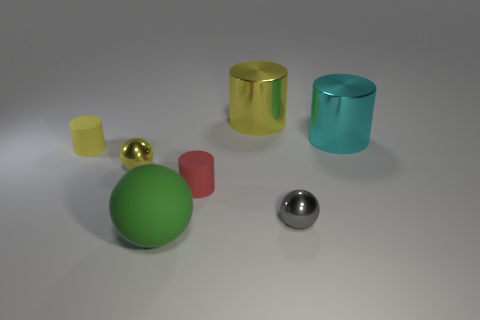What number of small things are red cylinders or green things?
Make the answer very short. 1. Is there a yellow metal cylinder that has the same size as the rubber sphere?
Keep it short and to the point. Yes. There is a small matte thing that is on the left side of the cylinder that is in front of the yellow metallic object that is in front of the big yellow object; what is its color?
Provide a succinct answer. Yellow. Does the green thing have the same material as the yellow cylinder that is behind the large cyan metal object?
Provide a succinct answer. No. There is a cyan shiny thing that is the same shape as the red object; what is its size?
Give a very brief answer. Large. Are there an equal number of yellow matte things on the right side of the yellow matte cylinder and tiny metal balls left of the matte sphere?
Your response must be concise. No. What number of other objects are the same material as the gray sphere?
Ensure brevity in your answer.  3. Are there an equal number of cyan things that are left of the small red cylinder and shiny cylinders?
Your answer should be very brief. No. Is the size of the yellow matte thing the same as the yellow cylinder to the right of the tiny red rubber thing?
Your answer should be very brief. No. There is a yellow metal object that is behind the yellow matte thing; what shape is it?
Your answer should be compact. Cylinder. 